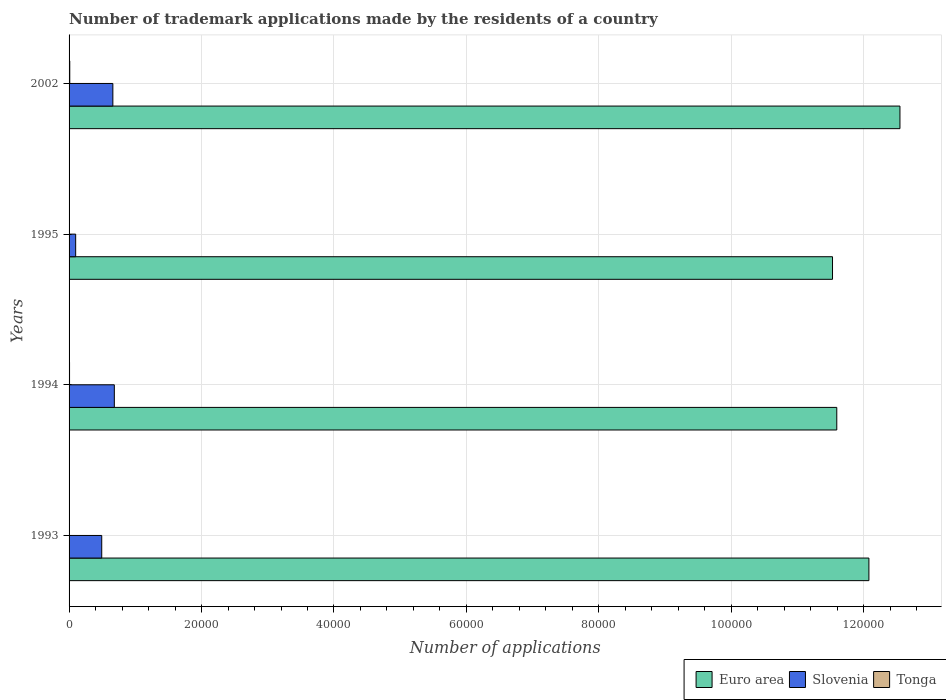How many different coloured bars are there?
Your response must be concise. 3. Are the number of bars per tick equal to the number of legend labels?
Provide a short and direct response. Yes. Are the number of bars on each tick of the Y-axis equal?
Your response must be concise. Yes. How many bars are there on the 2nd tick from the bottom?
Your answer should be very brief. 3. In how many cases, is the number of bars for a given year not equal to the number of legend labels?
Ensure brevity in your answer.  0. What is the number of trademark applications made by the residents in Slovenia in 1993?
Offer a very short reply. 4932. Across all years, what is the maximum number of trademark applications made by the residents in Euro area?
Your answer should be compact. 1.25e+05. In which year was the number of trademark applications made by the residents in Tonga maximum?
Your answer should be very brief. 2002. In which year was the number of trademark applications made by the residents in Slovenia minimum?
Provide a short and direct response. 1995. What is the total number of trademark applications made by the residents in Tonga in the graph?
Ensure brevity in your answer.  268. What is the difference between the number of trademark applications made by the residents in Euro area in 1994 and that in 1995?
Keep it short and to the point. 645. What is the difference between the number of trademark applications made by the residents in Euro area in 1993 and the number of trademark applications made by the residents in Slovenia in 2002?
Your answer should be compact. 1.14e+05. What is the average number of trademark applications made by the residents in Euro area per year?
Make the answer very short. 1.19e+05. In the year 2002, what is the difference between the number of trademark applications made by the residents in Tonga and number of trademark applications made by the residents in Euro area?
Your answer should be compact. -1.25e+05. What is the ratio of the number of trademark applications made by the residents in Slovenia in 1995 to that in 2002?
Offer a terse response. 0.15. Is the difference between the number of trademark applications made by the residents in Tonga in 1994 and 1995 greater than the difference between the number of trademark applications made by the residents in Euro area in 1994 and 1995?
Your answer should be compact. No. What is the difference between the highest and the second highest number of trademark applications made by the residents in Slovenia?
Your answer should be very brief. 221. What is the difference between the highest and the lowest number of trademark applications made by the residents in Slovenia?
Your answer should be very brief. 5836. In how many years, is the number of trademark applications made by the residents in Slovenia greater than the average number of trademark applications made by the residents in Slovenia taken over all years?
Provide a short and direct response. 3. What does the 2nd bar from the bottom in 1993 represents?
Your answer should be compact. Slovenia. How many bars are there?
Your answer should be very brief. 12. Are all the bars in the graph horizontal?
Offer a very short reply. Yes. Are the values on the major ticks of X-axis written in scientific E-notation?
Your answer should be compact. No. Does the graph contain any zero values?
Keep it short and to the point. No. What is the title of the graph?
Your answer should be very brief. Number of trademark applications made by the residents of a country. What is the label or title of the X-axis?
Give a very brief answer. Number of applications. What is the Number of applications in Euro area in 1993?
Offer a terse response. 1.21e+05. What is the Number of applications of Slovenia in 1993?
Keep it short and to the point. 4932. What is the Number of applications of Euro area in 1994?
Your answer should be compact. 1.16e+05. What is the Number of applications of Slovenia in 1994?
Offer a terse response. 6833. What is the Number of applications of Tonga in 1994?
Offer a very short reply. 73. What is the Number of applications of Euro area in 1995?
Your response must be concise. 1.15e+05. What is the Number of applications of Slovenia in 1995?
Keep it short and to the point. 997. What is the Number of applications in Tonga in 1995?
Offer a terse response. 45. What is the Number of applications of Euro area in 2002?
Make the answer very short. 1.25e+05. What is the Number of applications in Slovenia in 2002?
Offer a very short reply. 6612. What is the Number of applications in Tonga in 2002?
Your answer should be compact. 105. Across all years, what is the maximum Number of applications in Euro area?
Your answer should be very brief. 1.25e+05. Across all years, what is the maximum Number of applications in Slovenia?
Your response must be concise. 6833. Across all years, what is the maximum Number of applications in Tonga?
Offer a very short reply. 105. Across all years, what is the minimum Number of applications in Euro area?
Make the answer very short. 1.15e+05. Across all years, what is the minimum Number of applications of Slovenia?
Keep it short and to the point. 997. Across all years, what is the minimum Number of applications of Tonga?
Make the answer very short. 45. What is the total Number of applications in Euro area in the graph?
Your answer should be compact. 4.77e+05. What is the total Number of applications in Slovenia in the graph?
Your answer should be very brief. 1.94e+04. What is the total Number of applications of Tonga in the graph?
Provide a short and direct response. 268. What is the difference between the Number of applications of Euro area in 1993 and that in 1994?
Offer a very short reply. 4850. What is the difference between the Number of applications of Slovenia in 1993 and that in 1994?
Provide a short and direct response. -1901. What is the difference between the Number of applications in Tonga in 1993 and that in 1994?
Make the answer very short. -28. What is the difference between the Number of applications of Euro area in 1993 and that in 1995?
Provide a succinct answer. 5495. What is the difference between the Number of applications of Slovenia in 1993 and that in 1995?
Make the answer very short. 3935. What is the difference between the Number of applications of Euro area in 1993 and that in 2002?
Provide a succinct answer. -4687. What is the difference between the Number of applications in Slovenia in 1993 and that in 2002?
Make the answer very short. -1680. What is the difference between the Number of applications of Tonga in 1993 and that in 2002?
Offer a terse response. -60. What is the difference between the Number of applications of Euro area in 1994 and that in 1995?
Make the answer very short. 645. What is the difference between the Number of applications of Slovenia in 1994 and that in 1995?
Your response must be concise. 5836. What is the difference between the Number of applications of Tonga in 1994 and that in 1995?
Offer a terse response. 28. What is the difference between the Number of applications of Euro area in 1994 and that in 2002?
Keep it short and to the point. -9537. What is the difference between the Number of applications in Slovenia in 1994 and that in 2002?
Provide a short and direct response. 221. What is the difference between the Number of applications of Tonga in 1994 and that in 2002?
Your answer should be very brief. -32. What is the difference between the Number of applications of Euro area in 1995 and that in 2002?
Your response must be concise. -1.02e+04. What is the difference between the Number of applications in Slovenia in 1995 and that in 2002?
Make the answer very short. -5615. What is the difference between the Number of applications in Tonga in 1995 and that in 2002?
Keep it short and to the point. -60. What is the difference between the Number of applications in Euro area in 1993 and the Number of applications in Slovenia in 1994?
Make the answer very short. 1.14e+05. What is the difference between the Number of applications in Euro area in 1993 and the Number of applications in Tonga in 1994?
Make the answer very short. 1.21e+05. What is the difference between the Number of applications in Slovenia in 1993 and the Number of applications in Tonga in 1994?
Provide a short and direct response. 4859. What is the difference between the Number of applications in Euro area in 1993 and the Number of applications in Slovenia in 1995?
Ensure brevity in your answer.  1.20e+05. What is the difference between the Number of applications in Euro area in 1993 and the Number of applications in Tonga in 1995?
Make the answer very short. 1.21e+05. What is the difference between the Number of applications of Slovenia in 1993 and the Number of applications of Tonga in 1995?
Offer a terse response. 4887. What is the difference between the Number of applications in Euro area in 1993 and the Number of applications in Slovenia in 2002?
Offer a terse response. 1.14e+05. What is the difference between the Number of applications in Euro area in 1993 and the Number of applications in Tonga in 2002?
Ensure brevity in your answer.  1.21e+05. What is the difference between the Number of applications in Slovenia in 1993 and the Number of applications in Tonga in 2002?
Ensure brevity in your answer.  4827. What is the difference between the Number of applications of Euro area in 1994 and the Number of applications of Slovenia in 1995?
Your answer should be compact. 1.15e+05. What is the difference between the Number of applications of Euro area in 1994 and the Number of applications of Tonga in 1995?
Your answer should be compact. 1.16e+05. What is the difference between the Number of applications of Slovenia in 1994 and the Number of applications of Tonga in 1995?
Offer a terse response. 6788. What is the difference between the Number of applications in Euro area in 1994 and the Number of applications in Slovenia in 2002?
Offer a terse response. 1.09e+05. What is the difference between the Number of applications in Euro area in 1994 and the Number of applications in Tonga in 2002?
Give a very brief answer. 1.16e+05. What is the difference between the Number of applications in Slovenia in 1994 and the Number of applications in Tonga in 2002?
Provide a short and direct response. 6728. What is the difference between the Number of applications in Euro area in 1995 and the Number of applications in Slovenia in 2002?
Make the answer very short. 1.09e+05. What is the difference between the Number of applications of Euro area in 1995 and the Number of applications of Tonga in 2002?
Your answer should be compact. 1.15e+05. What is the difference between the Number of applications of Slovenia in 1995 and the Number of applications of Tonga in 2002?
Make the answer very short. 892. What is the average Number of applications of Euro area per year?
Make the answer very short. 1.19e+05. What is the average Number of applications of Slovenia per year?
Provide a succinct answer. 4843.5. What is the average Number of applications of Tonga per year?
Provide a short and direct response. 67. In the year 1993, what is the difference between the Number of applications of Euro area and Number of applications of Slovenia?
Keep it short and to the point. 1.16e+05. In the year 1993, what is the difference between the Number of applications in Euro area and Number of applications in Tonga?
Provide a short and direct response. 1.21e+05. In the year 1993, what is the difference between the Number of applications in Slovenia and Number of applications in Tonga?
Your answer should be very brief. 4887. In the year 1994, what is the difference between the Number of applications in Euro area and Number of applications in Slovenia?
Your answer should be compact. 1.09e+05. In the year 1994, what is the difference between the Number of applications of Euro area and Number of applications of Tonga?
Make the answer very short. 1.16e+05. In the year 1994, what is the difference between the Number of applications in Slovenia and Number of applications in Tonga?
Make the answer very short. 6760. In the year 1995, what is the difference between the Number of applications in Euro area and Number of applications in Slovenia?
Offer a very short reply. 1.14e+05. In the year 1995, what is the difference between the Number of applications of Euro area and Number of applications of Tonga?
Make the answer very short. 1.15e+05. In the year 1995, what is the difference between the Number of applications of Slovenia and Number of applications of Tonga?
Your answer should be very brief. 952. In the year 2002, what is the difference between the Number of applications of Euro area and Number of applications of Slovenia?
Your answer should be very brief. 1.19e+05. In the year 2002, what is the difference between the Number of applications of Euro area and Number of applications of Tonga?
Provide a succinct answer. 1.25e+05. In the year 2002, what is the difference between the Number of applications in Slovenia and Number of applications in Tonga?
Offer a very short reply. 6507. What is the ratio of the Number of applications in Euro area in 1993 to that in 1994?
Provide a succinct answer. 1.04. What is the ratio of the Number of applications of Slovenia in 1993 to that in 1994?
Make the answer very short. 0.72. What is the ratio of the Number of applications in Tonga in 1993 to that in 1994?
Provide a succinct answer. 0.62. What is the ratio of the Number of applications in Euro area in 1993 to that in 1995?
Make the answer very short. 1.05. What is the ratio of the Number of applications in Slovenia in 1993 to that in 1995?
Provide a succinct answer. 4.95. What is the ratio of the Number of applications of Euro area in 1993 to that in 2002?
Your answer should be compact. 0.96. What is the ratio of the Number of applications in Slovenia in 1993 to that in 2002?
Provide a short and direct response. 0.75. What is the ratio of the Number of applications in Tonga in 1993 to that in 2002?
Offer a very short reply. 0.43. What is the ratio of the Number of applications in Euro area in 1994 to that in 1995?
Provide a short and direct response. 1.01. What is the ratio of the Number of applications of Slovenia in 1994 to that in 1995?
Your answer should be very brief. 6.85. What is the ratio of the Number of applications of Tonga in 1994 to that in 1995?
Ensure brevity in your answer.  1.62. What is the ratio of the Number of applications in Euro area in 1994 to that in 2002?
Offer a terse response. 0.92. What is the ratio of the Number of applications of Slovenia in 1994 to that in 2002?
Give a very brief answer. 1.03. What is the ratio of the Number of applications of Tonga in 1994 to that in 2002?
Ensure brevity in your answer.  0.7. What is the ratio of the Number of applications in Euro area in 1995 to that in 2002?
Ensure brevity in your answer.  0.92. What is the ratio of the Number of applications of Slovenia in 1995 to that in 2002?
Ensure brevity in your answer.  0.15. What is the ratio of the Number of applications of Tonga in 1995 to that in 2002?
Offer a very short reply. 0.43. What is the difference between the highest and the second highest Number of applications of Euro area?
Offer a very short reply. 4687. What is the difference between the highest and the second highest Number of applications of Slovenia?
Provide a succinct answer. 221. What is the difference between the highest and the lowest Number of applications in Euro area?
Make the answer very short. 1.02e+04. What is the difference between the highest and the lowest Number of applications in Slovenia?
Make the answer very short. 5836. What is the difference between the highest and the lowest Number of applications of Tonga?
Offer a very short reply. 60. 